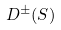<formula> <loc_0><loc_0><loc_500><loc_500>D ^ { \pm } ( S )</formula> 